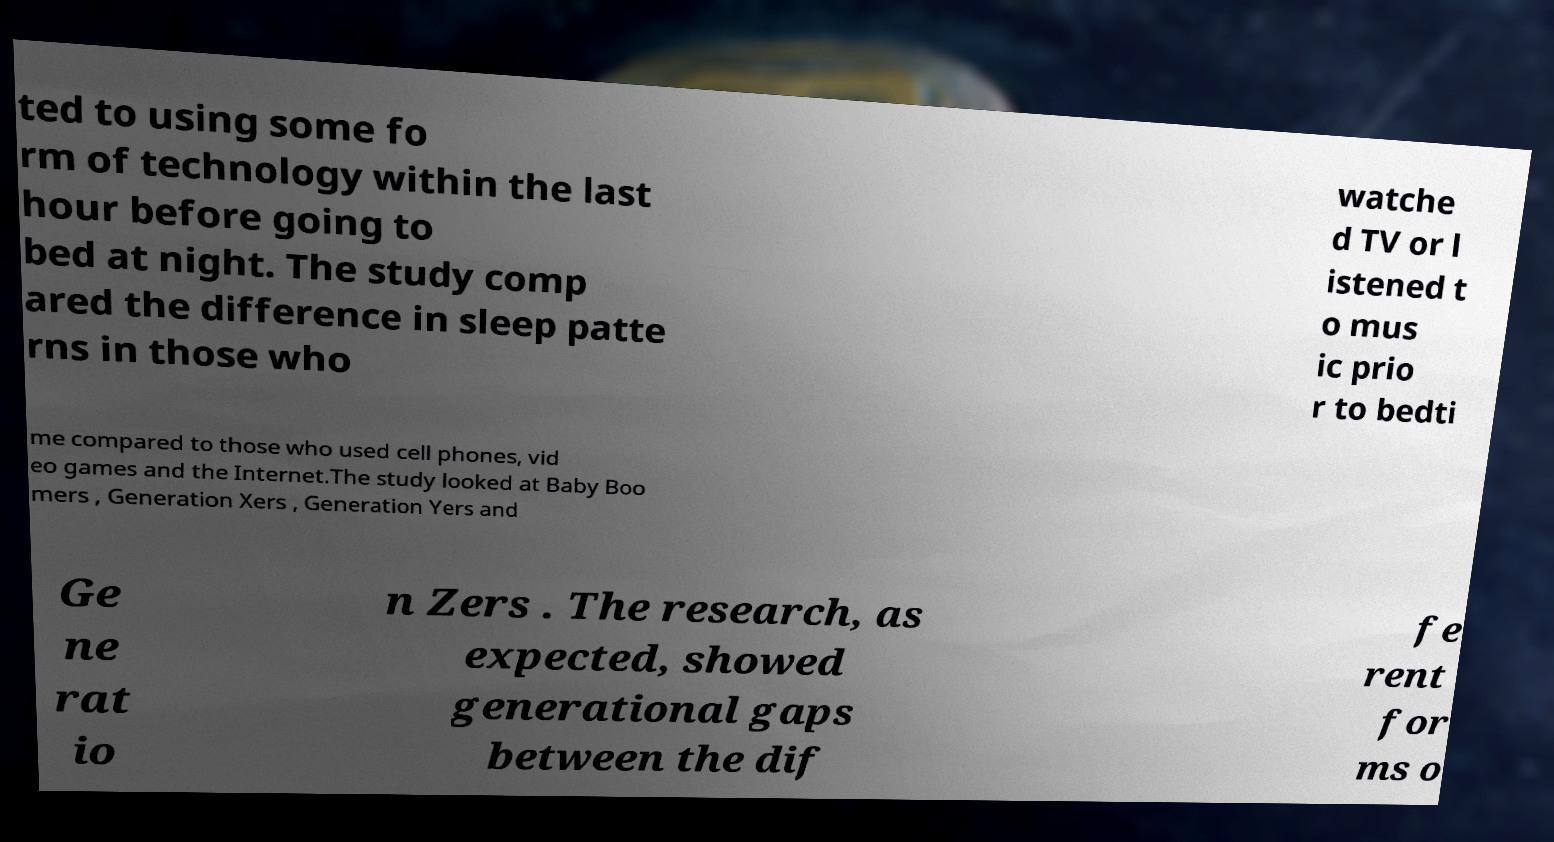Could you assist in decoding the text presented in this image and type it out clearly? ted to using some fo rm of technology within the last hour before going to bed at night. The study comp ared the difference in sleep patte rns in those who watche d TV or l istened t o mus ic prio r to bedti me compared to those who used cell phones, vid eo games and the Internet.The study looked at Baby Boo mers , Generation Xers , Generation Yers and Ge ne rat io n Zers . The research, as expected, showed generational gaps between the dif fe rent for ms o 